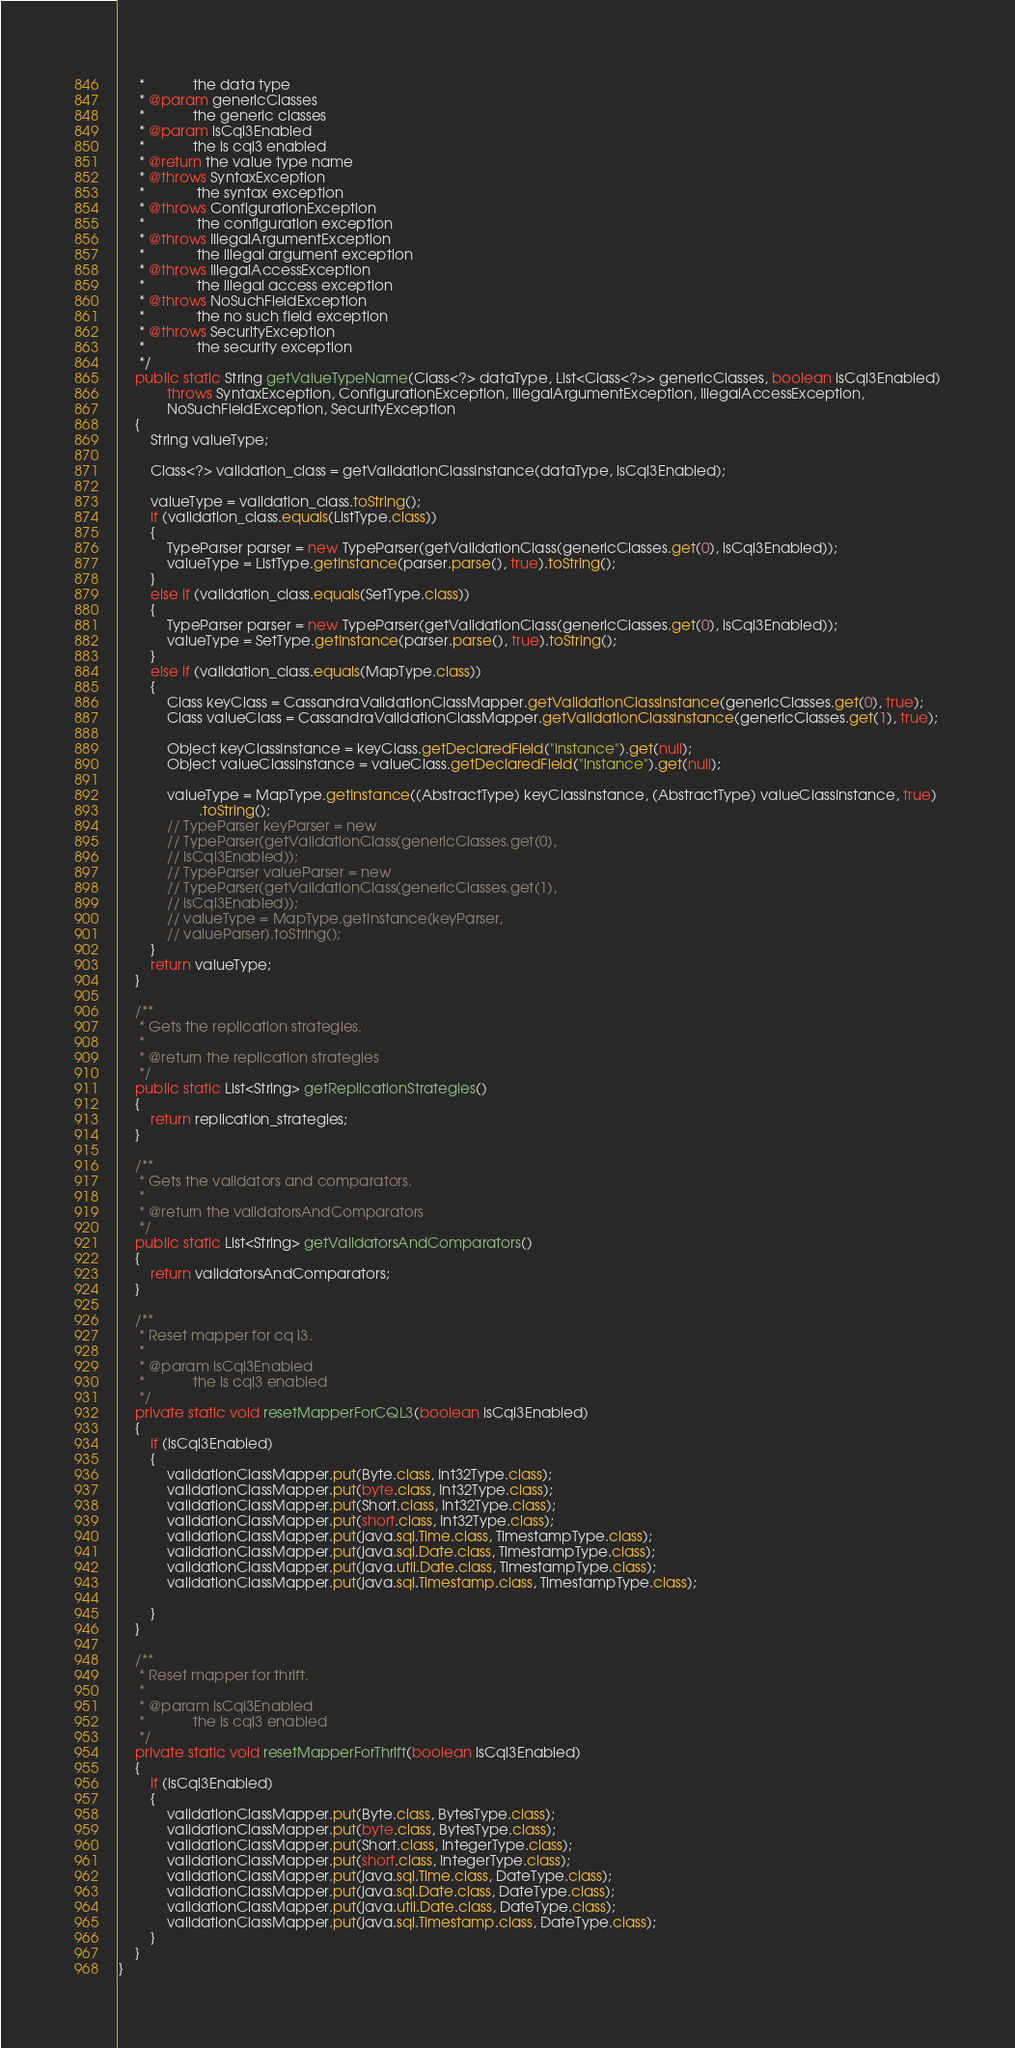<code> <loc_0><loc_0><loc_500><loc_500><_Java_>     *            the data type
     * @param genericClasses
     *            the generic classes
     * @param isCql3Enabled
     *            the is cql3 enabled
     * @return the value type name
     * @throws SyntaxException
     *             the syntax exception
     * @throws ConfigurationException
     *             the configuration exception
     * @throws IllegalArgumentException
     *             the illegal argument exception
     * @throws IllegalAccessException
     *             the illegal access exception
     * @throws NoSuchFieldException
     *             the no such field exception
     * @throws SecurityException
     *             the security exception
     */
    public static String getValueTypeName(Class<?> dataType, List<Class<?>> genericClasses, boolean isCql3Enabled)
            throws SyntaxException, ConfigurationException, IllegalArgumentException, IllegalAccessException,
            NoSuchFieldException, SecurityException
    {
        String valueType;

        Class<?> validation_class = getValidationClassInstance(dataType, isCql3Enabled);

        valueType = validation_class.toString();
        if (validation_class.equals(ListType.class))
        {
            TypeParser parser = new TypeParser(getValidationClass(genericClasses.get(0), isCql3Enabled));
            valueType = ListType.getInstance(parser.parse(), true).toString();
        }
        else if (validation_class.equals(SetType.class))
        {
            TypeParser parser = new TypeParser(getValidationClass(genericClasses.get(0), isCql3Enabled));
            valueType = SetType.getInstance(parser.parse(), true).toString();
        }
        else if (validation_class.equals(MapType.class))
        {
            Class keyClass = CassandraValidationClassMapper.getValidationClassInstance(genericClasses.get(0), true);
            Class valueClass = CassandraValidationClassMapper.getValidationClassInstance(genericClasses.get(1), true);

            Object keyClassInstance = keyClass.getDeclaredField("instance").get(null);
            Object valueClassInstance = valueClass.getDeclaredField("instance").get(null);

            valueType = MapType.getInstance((AbstractType) keyClassInstance, (AbstractType) valueClassInstance, true)
                    .toString();
            // TypeParser keyParser = new
            // TypeParser(getValidationClass(genericClasses.get(0),
            // isCql3Enabled));
            // TypeParser valueParser = new
            // TypeParser(getValidationClass(genericClasses.get(1),
            // isCql3Enabled));
            // valueType = MapType.getInstance(keyParser,
            // valueParser).toString();
        }
        return valueType;
    }

    /**
     * Gets the replication strategies.
     * 
     * @return the replication strategies
     */
    public static List<String> getReplicationStrategies()
    {
        return replication_strategies;
    }

    /**
     * Gets the validators and comparators.
     * 
     * @return the validatorsAndComparators
     */
    public static List<String> getValidatorsAndComparators()
    {
        return validatorsAndComparators;
    }

    /**
     * Reset mapper for cq l3.
     * 
     * @param isCql3Enabled
     *            the is cql3 enabled
     */
    private static void resetMapperForCQL3(boolean isCql3Enabled)
    {
        if (isCql3Enabled)
        {
            validationClassMapper.put(Byte.class, Int32Type.class);
            validationClassMapper.put(byte.class, Int32Type.class);
            validationClassMapper.put(Short.class, Int32Type.class);
            validationClassMapper.put(short.class, Int32Type.class);
            validationClassMapper.put(java.sql.Time.class, TimestampType.class);
            validationClassMapper.put(java.sql.Date.class, TimestampType.class);
            validationClassMapper.put(java.util.Date.class, TimestampType.class);
            validationClassMapper.put(java.sql.Timestamp.class, TimestampType.class);

        }
    }

    /**
     * Reset mapper for thrift.
     * 
     * @param isCql3Enabled
     *            the is cql3 enabled
     */
    private static void resetMapperForThrift(boolean isCql3Enabled)
    {
        if (isCql3Enabled)
        {
            validationClassMapper.put(Byte.class, BytesType.class);
            validationClassMapper.put(byte.class, BytesType.class);
            validationClassMapper.put(Short.class, IntegerType.class);
            validationClassMapper.put(short.class, IntegerType.class);
            validationClassMapper.put(java.sql.Time.class, DateType.class);
            validationClassMapper.put(java.sql.Date.class, DateType.class);
            validationClassMapper.put(java.util.Date.class, DateType.class);
            validationClassMapper.put(java.sql.Timestamp.class, DateType.class);
        }
    }
}</code> 